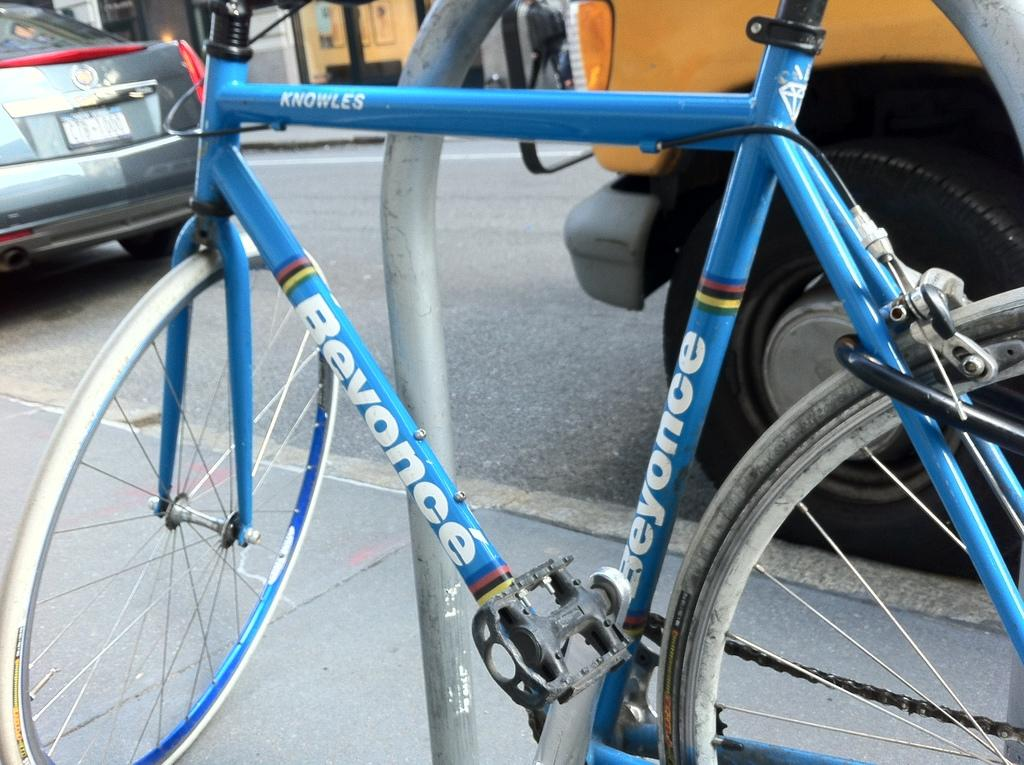What is the main subject of the picture? The main subject of the picture is a bicycle. What color is the bicycle? The bicycle is blue in color. What else can be seen on the road in the picture? There are vehicles on the road in the picture. What is written on the bicycle? Something is written on the bicycle. What other objects are visible in the background of the image? There are other objects visible in the background of the image. What time of day is it in the image, considering it's the afternoon? The provided facts do not mention the time of day, and there is no indication of it being the afternoon in the image. 